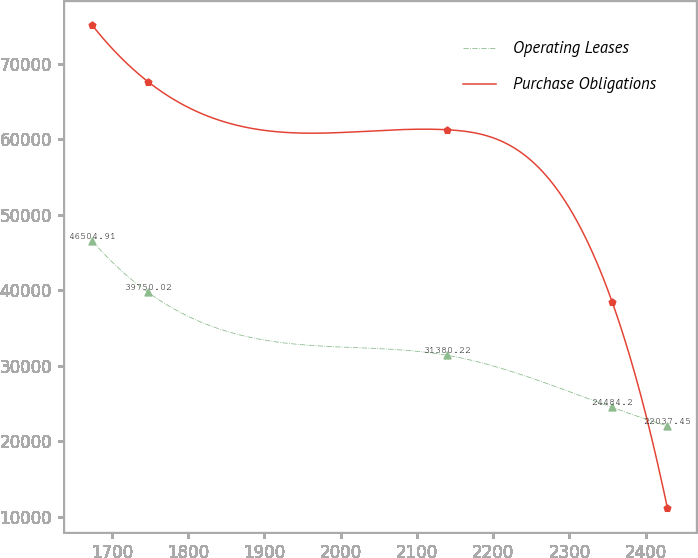Convert chart to OTSL. <chart><loc_0><loc_0><loc_500><loc_500><line_chart><ecel><fcel>Operating Leases<fcel>Purchase Obligations<nl><fcel>1674.43<fcel>46504.9<fcel>75092.2<nl><fcel>1747.01<fcel>39750<fcel>67666.9<nl><fcel>2139.9<fcel>31380.2<fcel>61273.1<nl><fcel>2355.87<fcel>24484.2<fcel>38501.4<nl><fcel>2428.45<fcel>22037.5<fcel>11154.1<nl></chart> 